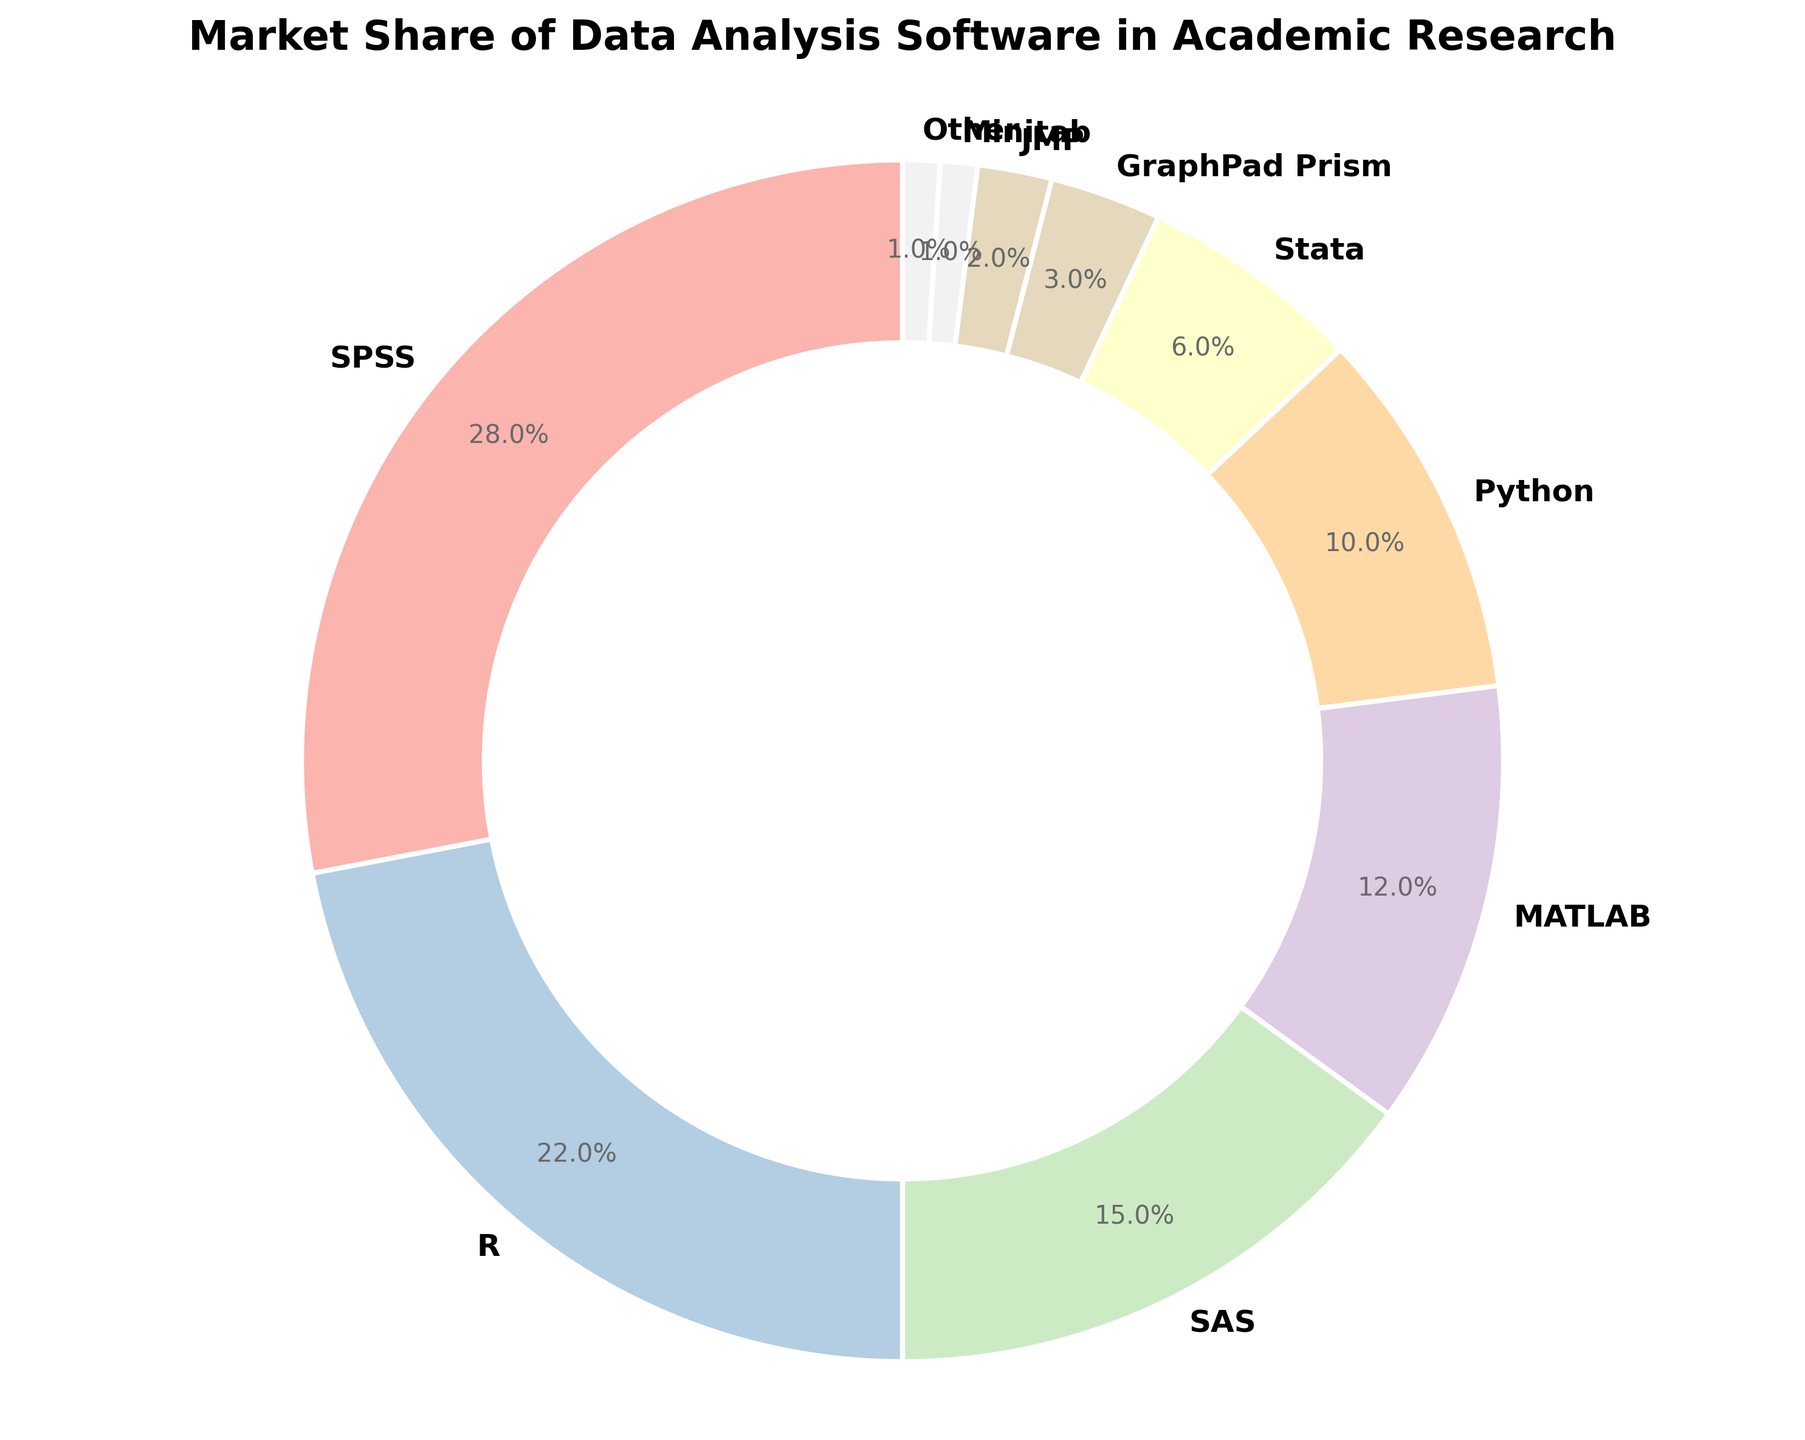What's the software with the highest market share? SPSS has the highest percentage in the pie chart. The figure indicates that SPSS occupies 28% of the market, which is more than any other software.
Answer: SPSS Which software has the lowest market share, and what is its percentage? The figure shows that Minitab and 'Other' have the smallest slices in the pie chart. Each of these software occupies only 1% of the market.
Answer: Minitab and Other, 1% What's the combined market share of R and Python? According to the chart, R holds 22% and Python holds 10%. Summing these values gives 22% + 10% = 32%.
Answer: 32% How much greater is the market share of SPSS compared to Stata? SPSS has 28% market share, while Stata has 6%. The difference is 28% - 6% = 22%.
Answer: 22% What is the market share difference between MATLAB and JMP? MATLAB holds 12% of the market and JMP holds 2%. The difference is 12% - 2% = 10%.
Answer: 10% Arrange the top three software by market share. According to the pie chart, the top three software by market share are SPSS (28%), R (22%), and SAS (15%).
Answer: SPSS, R, SAS If the market share of 'Other' increased by 5%, what would be the new market share for 'Other'? 'Other' currently has 1% market share. An increase of 5% results in a new market share of 1% + 5% = 6%.
Answer: 6% Which software has a market share closest to 10%, and what exactly is its market share? Python's segment in the pie chart closely matches this description. Python has exactly 10%.
Answer: Python, 10% What is the market share of all non-top-three software combined? The top three software are SPSS (28%), R (22%), and SAS (15%), which sum to 65%. Therefore, the combined market share of all non-top-three software is 100% - 65% = 35%.
Answer: 35% What is the difference in market share between the software with the largest share and the one with the second largest share? SPSS has the highest market share with 28%, and R is second with 22%. The difference is 28% - 22% = 6%.
Answer: 6% 